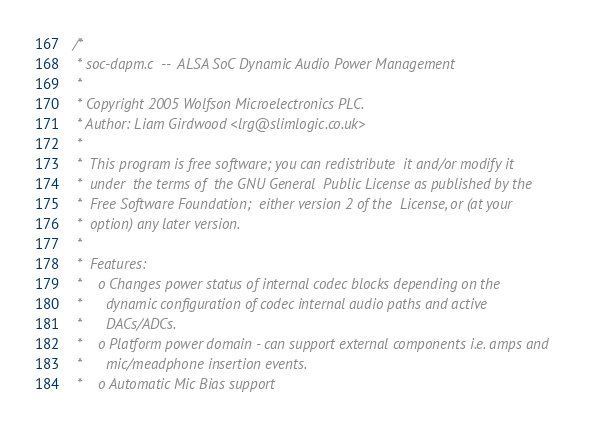<code> <loc_0><loc_0><loc_500><loc_500><_C_>/*
 * soc-dapm.c  --  ALSA SoC Dynamic Audio Power Management
 *
 * Copyright 2005 Wolfson Microelectronics PLC.
 * Author: Liam Girdwood <lrg@slimlogic.co.uk>
 *
 *  This program is free software; you can redistribute  it and/or modify it
 *  under  the terms of  the GNU General  Public License as published by the
 *  Free Software Foundation;  either version 2 of the  License, or (at your
 *  option) any later version.
 *
 *  Features:
 *    o Changes power status of internal codec blocks depending on the
 *      dynamic configuration of codec internal audio paths and active
 *      DACs/ADCs.
 *    o Platform power domain - can support external components i.e. amps and
 *      mic/meadphone insertion events.
 *    o Automatic Mic Bias support</code> 